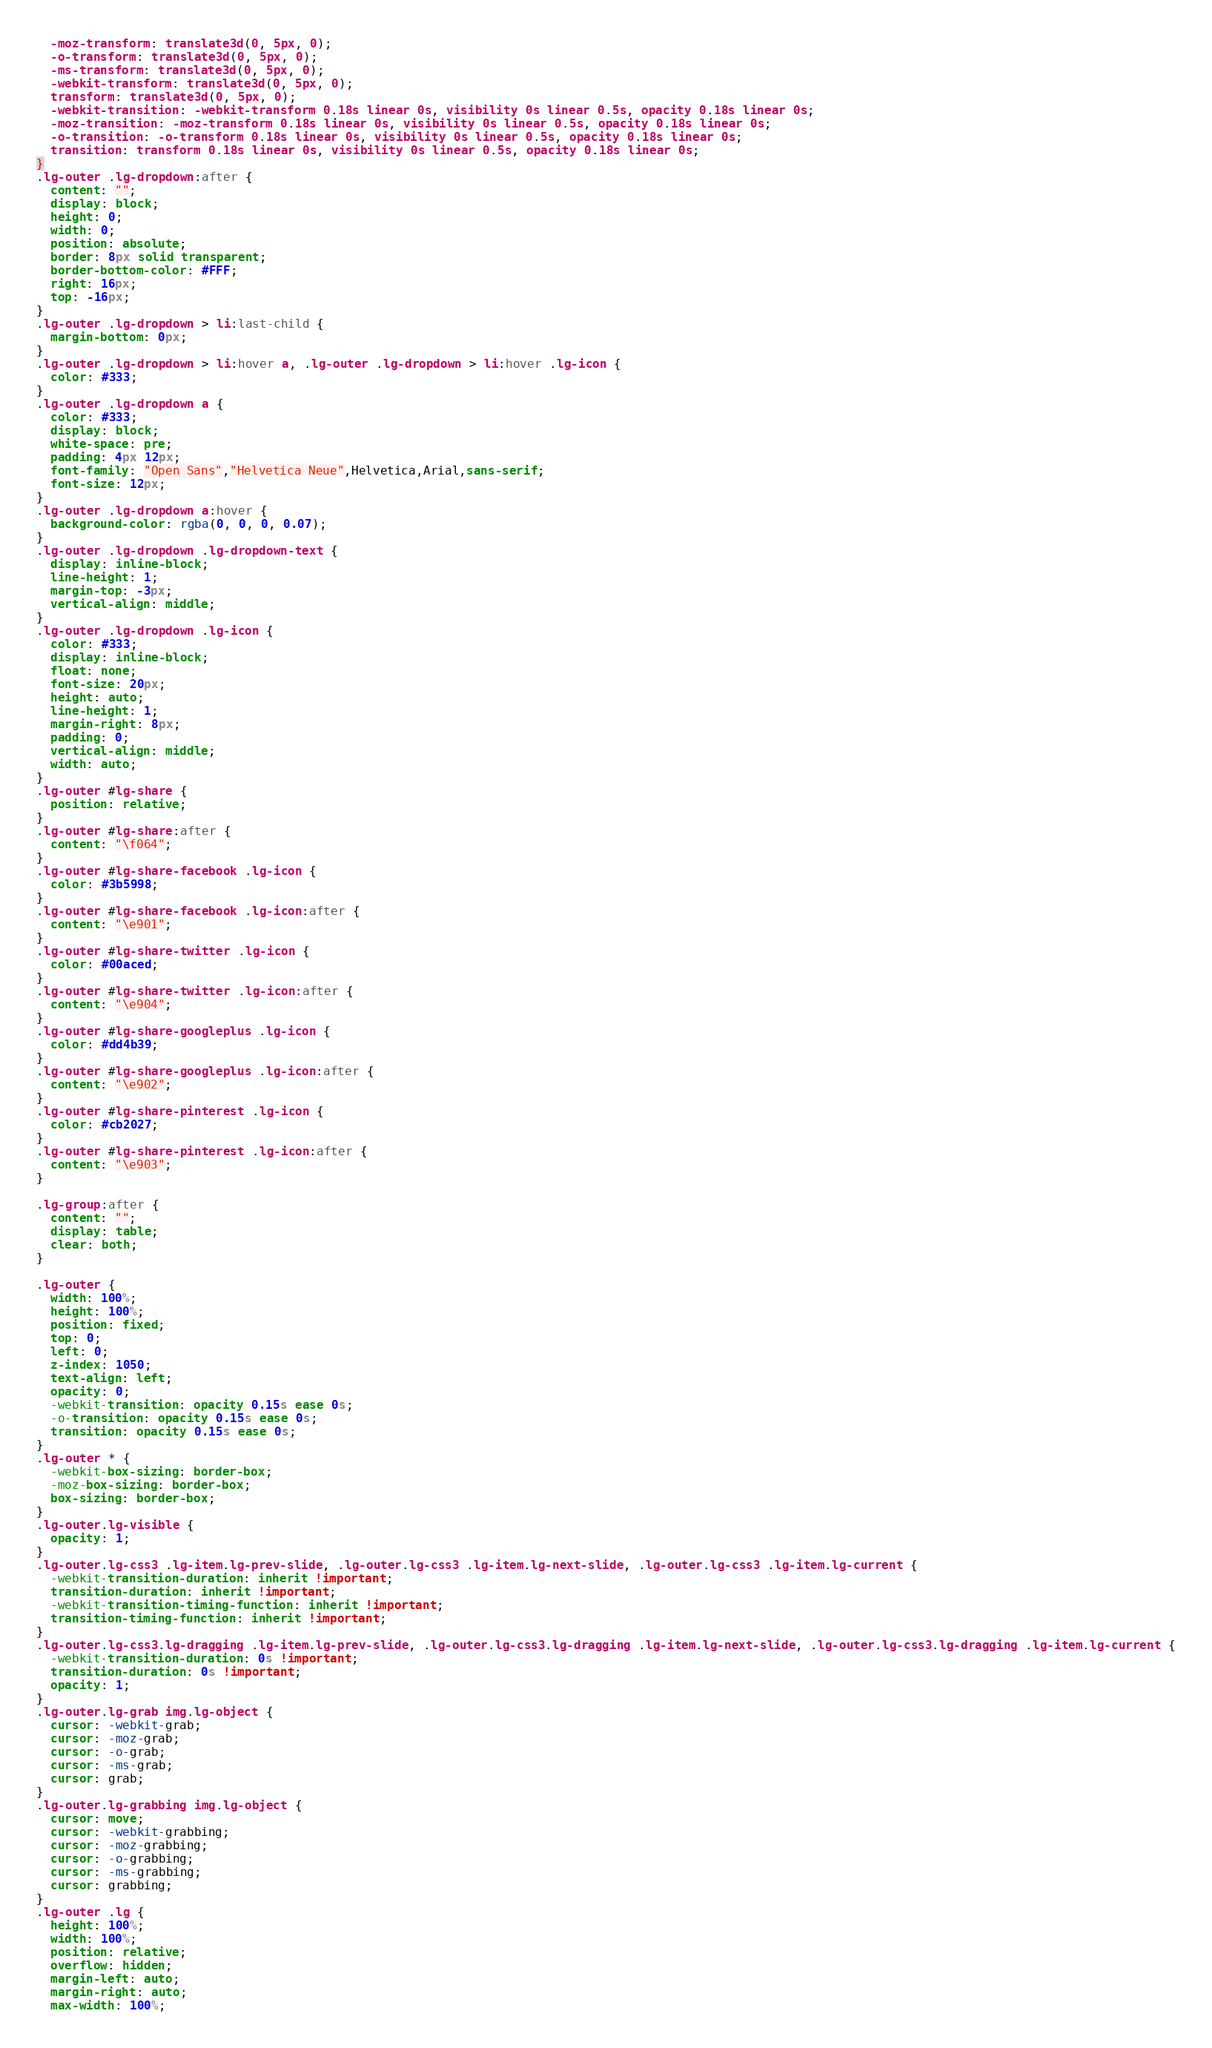Convert code to text. <code><loc_0><loc_0><loc_500><loc_500><_CSS_>  -moz-transform: translate3d(0, 5px, 0);
  -o-transform: translate3d(0, 5px, 0);
  -ms-transform: translate3d(0, 5px, 0);
  -webkit-transform: translate3d(0, 5px, 0);
  transform: translate3d(0, 5px, 0);
  -webkit-transition: -webkit-transform 0.18s linear 0s, visibility 0s linear 0.5s, opacity 0.18s linear 0s;
  -moz-transition: -moz-transform 0.18s linear 0s, visibility 0s linear 0.5s, opacity 0.18s linear 0s;
  -o-transition: -o-transform 0.18s linear 0s, visibility 0s linear 0.5s, opacity 0.18s linear 0s;
  transition: transform 0.18s linear 0s, visibility 0s linear 0.5s, opacity 0.18s linear 0s;
}
.lg-outer .lg-dropdown:after {
  content: "";
  display: block;
  height: 0;
  width: 0;
  position: absolute;
  border: 8px solid transparent;
  border-bottom-color: #FFF;
  right: 16px;
  top: -16px;
}
.lg-outer .lg-dropdown > li:last-child {
  margin-bottom: 0px;
}
.lg-outer .lg-dropdown > li:hover a, .lg-outer .lg-dropdown > li:hover .lg-icon {
  color: #333;
}
.lg-outer .lg-dropdown a {
  color: #333;
  display: block;
  white-space: pre;
  padding: 4px 12px;
  font-family: "Open Sans","Helvetica Neue",Helvetica,Arial,sans-serif;
  font-size: 12px;
}
.lg-outer .lg-dropdown a:hover {
  background-color: rgba(0, 0, 0, 0.07);
}
.lg-outer .lg-dropdown .lg-dropdown-text {
  display: inline-block;
  line-height: 1;
  margin-top: -3px;
  vertical-align: middle;
}
.lg-outer .lg-dropdown .lg-icon {
  color: #333;
  display: inline-block;
  float: none;
  font-size: 20px;
  height: auto;
  line-height: 1;
  margin-right: 8px;
  padding: 0;
  vertical-align: middle;
  width: auto;
}
.lg-outer #lg-share {
  position: relative;
}
.lg-outer #lg-share:after {
  content: "\f064";
}
.lg-outer #lg-share-facebook .lg-icon {
  color: #3b5998;
}
.lg-outer #lg-share-facebook .lg-icon:after {
  content: "\e901";
}
.lg-outer #lg-share-twitter .lg-icon {
  color: #00aced;
}
.lg-outer #lg-share-twitter .lg-icon:after {
  content: "\e904";
}
.lg-outer #lg-share-googleplus .lg-icon {
  color: #dd4b39;
}
.lg-outer #lg-share-googleplus .lg-icon:after {
  content: "\e902";
}
.lg-outer #lg-share-pinterest .lg-icon {
  color: #cb2027;
}
.lg-outer #lg-share-pinterest .lg-icon:after {
  content: "\e903";
}

.lg-group:after {
  content: "";
  display: table;
  clear: both;
}

.lg-outer {
  width: 100%;
  height: 100%;
  position: fixed;
  top: 0;
  left: 0;
  z-index: 1050;
  text-align: left;
  opacity: 0;
  -webkit-transition: opacity 0.15s ease 0s;
  -o-transition: opacity 0.15s ease 0s;
  transition: opacity 0.15s ease 0s;
}
.lg-outer * {
  -webkit-box-sizing: border-box;
  -moz-box-sizing: border-box;
  box-sizing: border-box;
}
.lg-outer.lg-visible {
  opacity: 1;
}
.lg-outer.lg-css3 .lg-item.lg-prev-slide, .lg-outer.lg-css3 .lg-item.lg-next-slide, .lg-outer.lg-css3 .lg-item.lg-current {
  -webkit-transition-duration: inherit !important;
  transition-duration: inherit !important;
  -webkit-transition-timing-function: inherit !important;
  transition-timing-function: inherit !important;
}
.lg-outer.lg-css3.lg-dragging .lg-item.lg-prev-slide, .lg-outer.lg-css3.lg-dragging .lg-item.lg-next-slide, .lg-outer.lg-css3.lg-dragging .lg-item.lg-current {
  -webkit-transition-duration: 0s !important;
  transition-duration: 0s !important;
  opacity: 1;
}
.lg-outer.lg-grab img.lg-object {
  cursor: -webkit-grab;
  cursor: -moz-grab;
  cursor: -o-grab;
  cursor: -ms-grab;
  cursor: grab;
}
.lg-outer.lg-grabbing img.lg-object {
  cursor: move;
  cursor: -webkit-grabbing;
  cursor: -moz-grabbing;
  cursor: -o-grabbing;
  cursor: -ms-grabbing;
  cursor: grabbing;
}
.lg-outer .lg {
  height: 100%;
  width: 100%;
  position: relative;
  overflow: hidden;
  margin-left: auto;
  margin-right: auto;
  max-width: 100%;</code> 